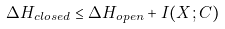<formula> <loc_0><loc_0><loc_500><loc_500>\Delta H _ { c l o s e d } \leq \Delta H _ { o p e n } + I ( X ; C )</formula> 